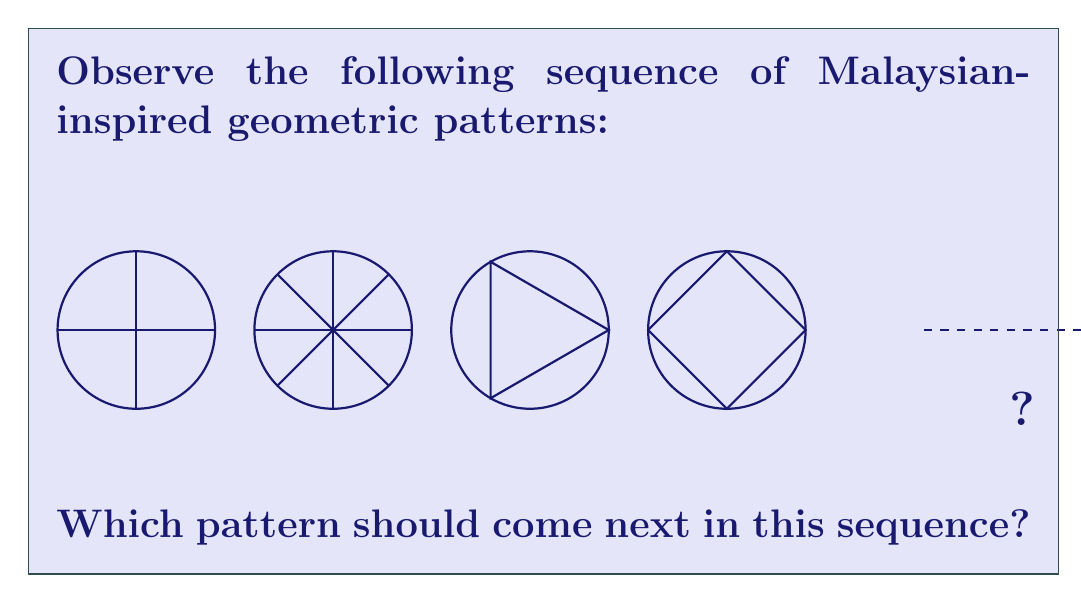Can you solve this math problem? To solve this problem, we need to analyze the patterns in the sequence and identify the rule governing their progression. Let's break it down step by step:

1. Pattern 1: A circle with two perpendicular lines crossing at the center, forming four equal segments.

2. Pattern 2: A circle with eight equally spaced radial lines, dividing the circle into eight segments.

3. Pattern 3: A circle with an inscribed equilateral triangle.

4. Pattern 4: A circle with an inscribed square.

The progression we observe is:
- The number of sides in the inscribed regular polygon increases by 1 each time.
- Pattern 1 has a 2-sided "polygon" (the perpendicular lines).
- Pattern 2 has an 8-sided polygon (octagon, represented by the 8 radial lines).
- Pattern 3 has a 3-sided polygon (triangle).
- Pattern 4 has a 4-sided polygon (square).

Following this logic, the next pattern in the sequence should have a 5-sided regular polygon (pentagon) inscribed in the circle.

This progression is reminiscent of the geometric patterns found in Malaysian Islamic art, where circles and regular polygons are often combined to create intricate designs. The increasing number of sides in the inscribed polygons could symbolize the complexity and beauty of Malaysian geometric art, which Nazhan Zulkifle, as a Malaysian artist, might appreciate.
Answer: A circle with an inscribed regular pentagon 